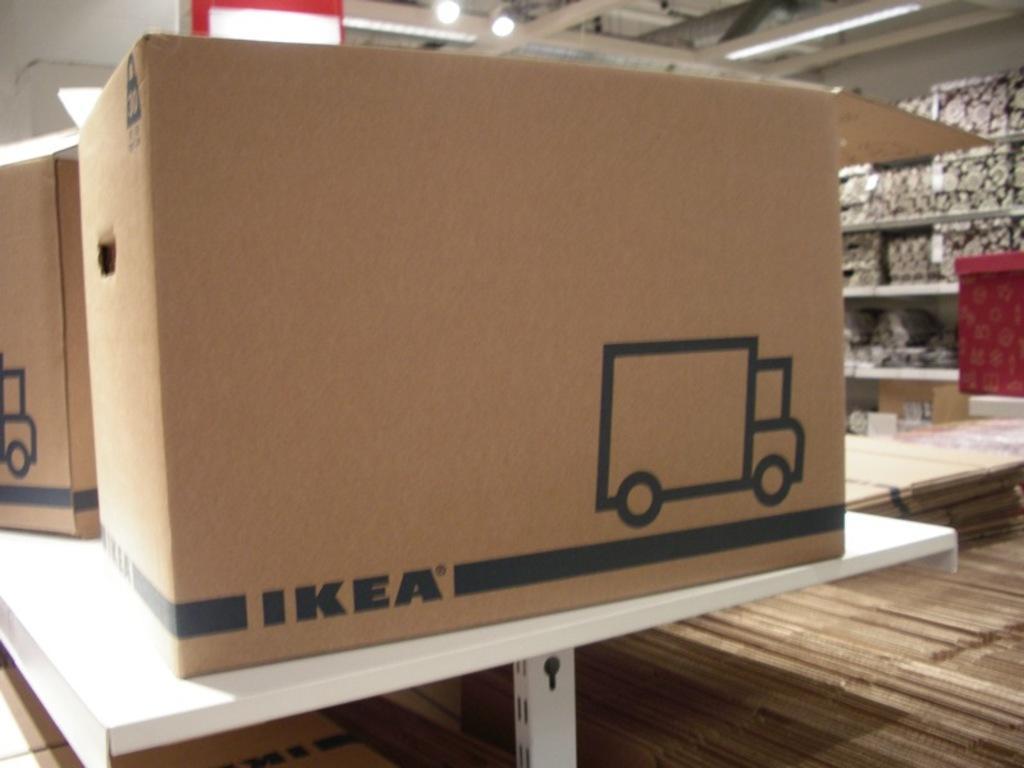Please provide a concise description of this image. In the middle of the image we can see a table, on the table we can see a some boxes. Behind the boxes we can see a rack, in the rack we can see some objects. At the top of the image we can see ceiling and lights. 